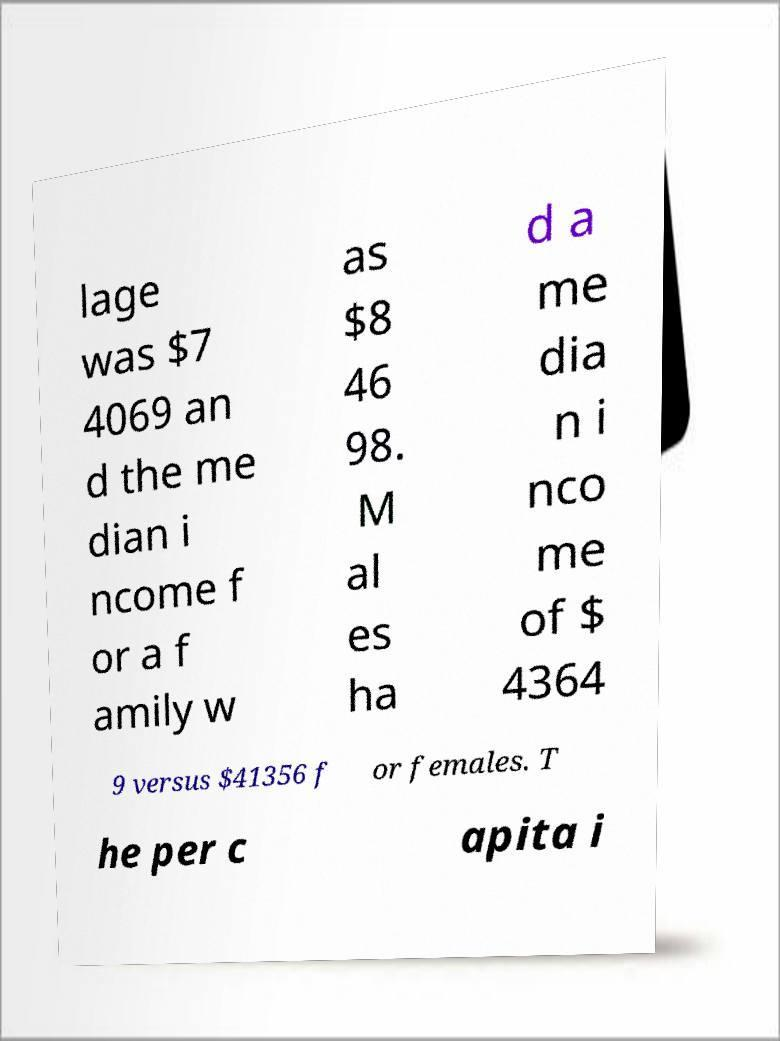Could you assist in decoding the text presented in this image and type it out clearly? lage was $7 4069 an d the me dian i ncome f or a f amily w as $8 46 98. M al es ha d a me dia n i nco me of $ 4364 9 versus $41356 f or females. T he per c apita i 